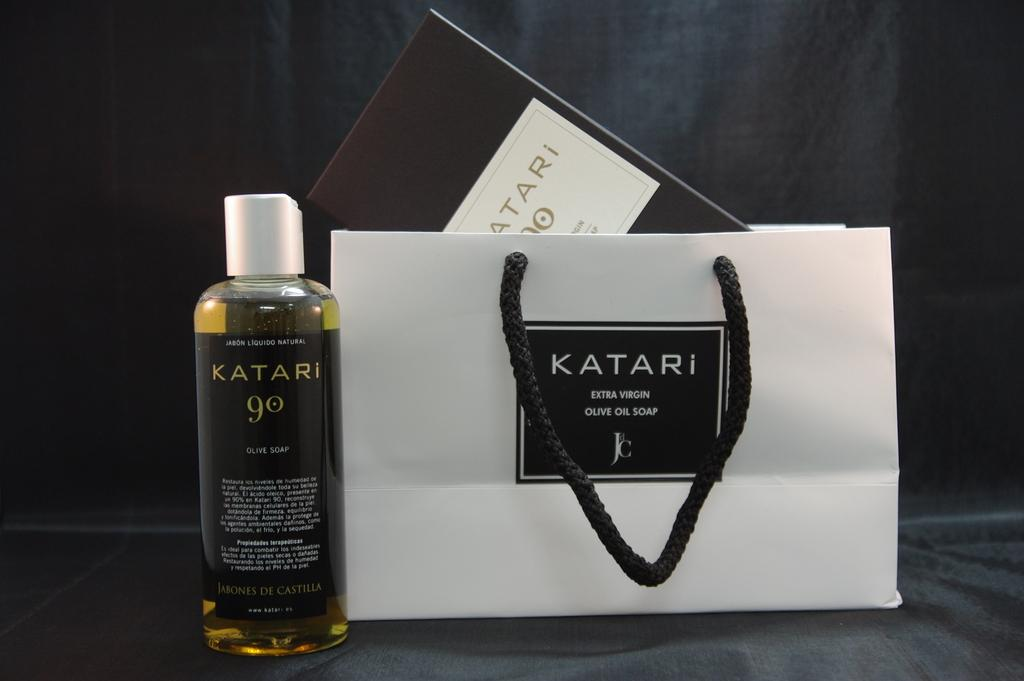<image>
Write a terse but informative summary of the picture. A gift bag from Katari ExtraVirgin Olive Oil Soap with a bottle of the product next to it. 